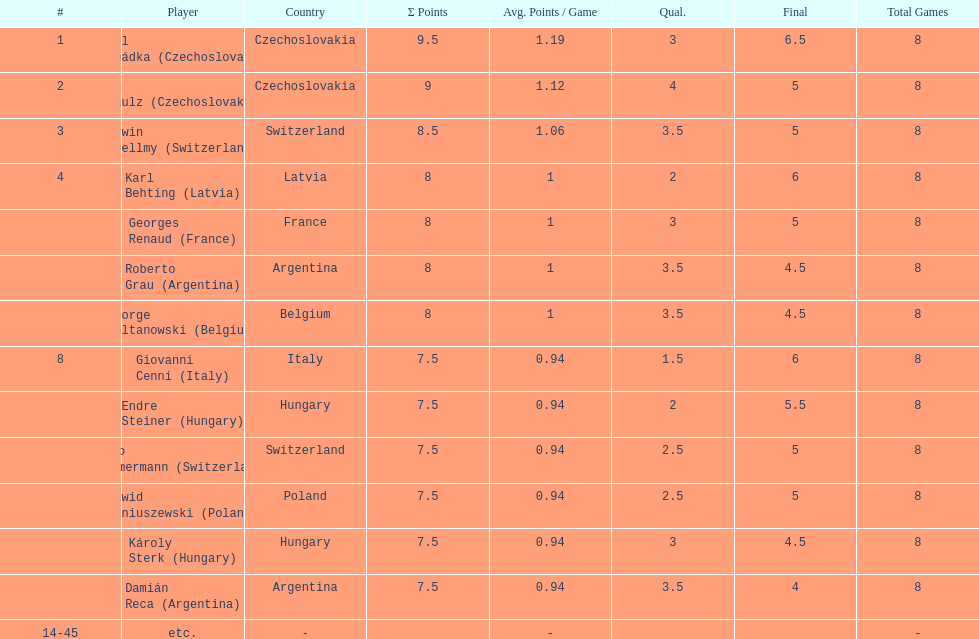How many players tied for 4th place? 4. 